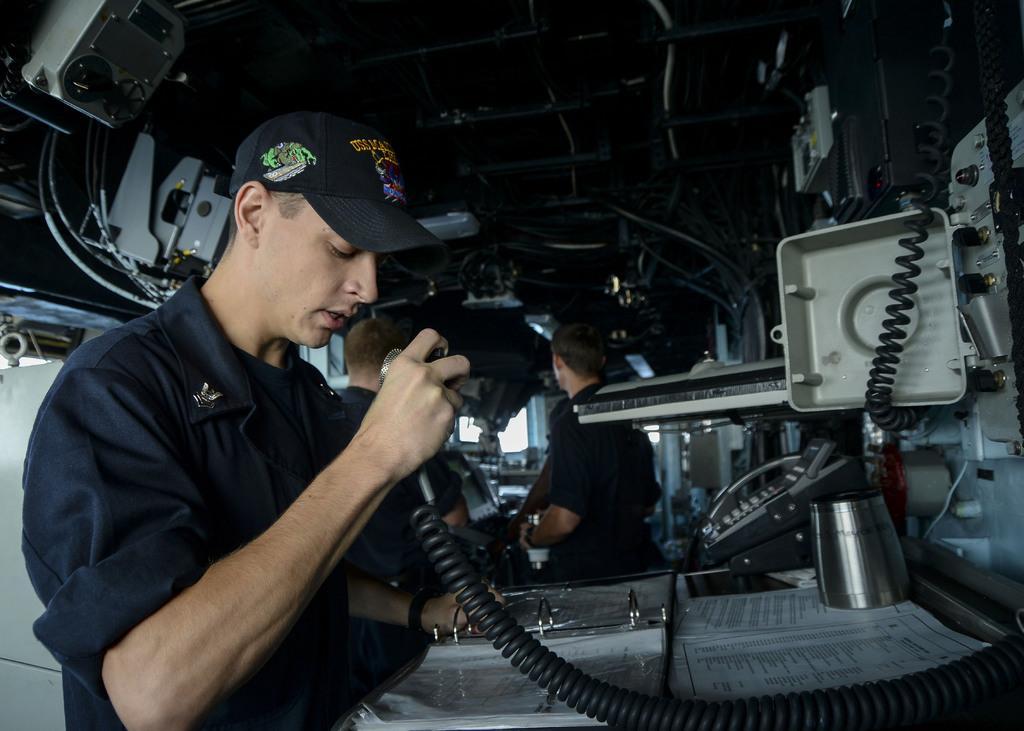How would you summarize this image in a sentence or two? This picture is clicked inside the vehicle. On the left there is a person standing on the ground and holding an object. On the right we can see there are some objects placed on the top of the table. In the background we can see the roof, machines and a person. 